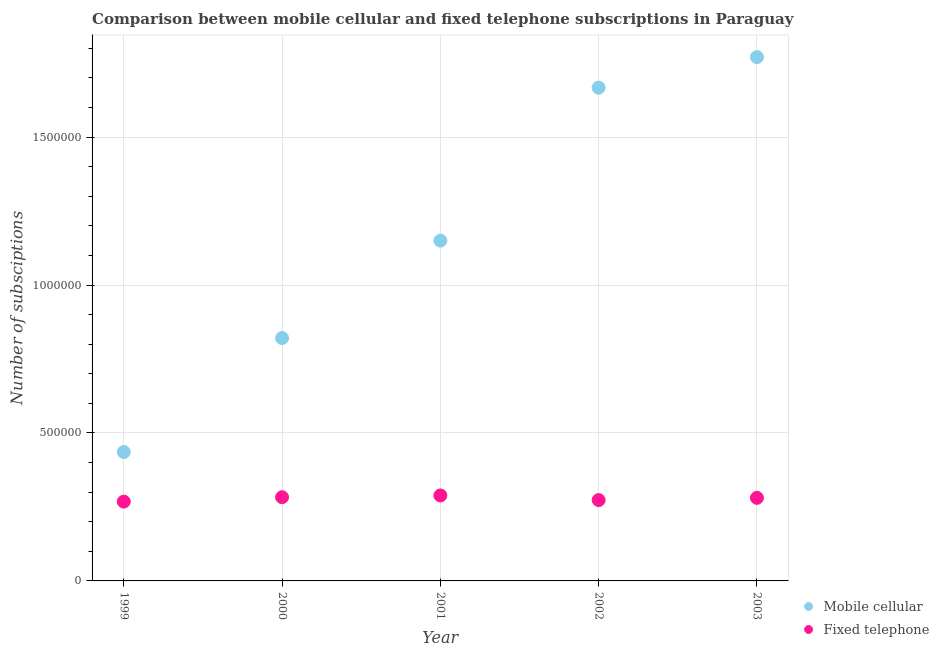What is the number of mobile cellular subscriptions in 1999?
Give a very brief answer. 4.36e+05. Across all years, what is the maximum number of fixed telephone subscriptions?
Offer a very short reply. 2.89e+05. Across all years, what is the minimum number of fixed telephone subscriptions?
Offer a very short reply. 2.68e+05. What is the total number of mobile cellular subscriptions in the graph?
Offer a very short reply. 5.84e+06. What is the difference between the number of mobile cellular subscriptions in 1999 and that in 2001?
Offer a very short reply. -7.14e+05. What is the difference between the number of mobile cellular subscriptions in 2001 and the number of fixed telephone subscriptions in 2000?
Your answer should be very brief. 8.67e+05. What is the average number of fixed telephone subscriptions per year?
Your response must be concise. 2.79e+05. In the year 2003, what is the difference between the number of mobile cellular subscriptions and number of fixed telephone subscriptions?
Provide a short and direct response. 1.49e+06. In how many years, is the number of fixed telephone subscriptions greater than 500000?
Keep it short and to the point. 0. What is the ratio of the number of fixed telephone subscriptions in 1999 to that in 2000?
Provide a short and direct response. 0.95. Is the difference between the number of mobile cellular subscriptions in 2000 and 2003 greater than the difference between the number of fixed telephone subscriptions in 2000 and 2003?
Give a very brief answer. No. What is the difference between the highest and the second highest number of mobile cellular subscriptions?
Keep it short and to the point. 1.03e+05. What is the difference between the highest and the lowest number of fixed telephone subscriptions?
Your answer should be very brief. 2.07e+04. Is the sum of the number of fixed telephone subscriptions in 2001 and 2002 greater than the maximum number of mobile cellular subscriptions across all years?
Offer a very short reply. No. Does the number of mobile cellular subscriptions monotonically increase over the years?
Ensure brevity in your answer.  Yes. Is the number of mobile cellular subscriptions strictly greater than the number of fixed telephone subscriptions over the years?
Offer a very short reply. Yes. Is the number of fixed telephone subscriptions strictly less than the number of mobile cellular subscriptions over the years?
Your response must be concise. Yes. Are the values on the major ticks of Y-axis written in scientific E-notation?
Offer a terse response. No. Does the graph contain any zero values?
Offer a very short reply. No. Does the graph contain grids?
Your response must be concise. Yes. What is the title of the graph?
Offer a terse response. Comparison between mobile cellular and fixed telephone subscriptions in Paraguay. Does "Drinking water services" appear as one of the legend labels in the graph?
Offer a terse response. No. What is the label or title of the X-axis?
Your answer should be very brief. Year. What is the label or title of the Y-axis?
Keep it short and to the point. Number of subsciptions. What is the Number of subsciptions of Mobile cellular in 1999?
Offer a very short reply. 4.36e+05. What is the Number of subsciptions of Fixed telephone in 1999?
Offer a very short reply. 2.68e+05. What is the Number of subsciptions of Mobile cellular in 2000?
Your response must be concise. 8.21e+05. What is the Number of subsciptions of Fixed telephone in 2000?
Keep it short and to the point. 2.83e+05. What is the Number of subsciptions of Mobile cellular in 2001?
Give a very brief answer. 1.15e+06. What is the Number of subsciptions of Fixed telephone in 2001?
Your answer should be very brief. 2.89e+05. What is the Number of subsciptions of Mobile cellular in 2002?
Give a very brief answer. 1.67e+06. What is the Number of subsciptions in Fixed telephone in 2002?
Provide a succinct answer. 2.73e+05. What is the Number of subsciptions of Mobile cellular in 2003?
Provide a succinct answer. 1.77e+06. What is the Number of subsciptions of Fixed telephone in 2003?
Your answer should be very brief. 2.81e+05. Across all years, what is the maximum Number of subsciptions of Mobile cellular?
Provide a short and direct response. 1.77e+06. Across all years, what is the maximum Number of subsciptions in Fixed telephone?
Provide a succinct answer. 2.89e+05. Across all years, what is the minimum Number of subsciptions of Mobile cellular?
Your answer should be very brief. 4.36e+05. Across all years, what is the minimum Number of subsciptions in Fixed telephone?
Your response must be concise. 2.68e+05. What is the total Number of subsciptions of Mobile cellular in the graph?
Offer a very short reply. 5.84e+06. What is the total Number of subsciptions in Fixed telephone in the graph?
Your answer should be compact. 1.39e+06. What is the difference between the Number of subsciptions in Mobile cellular in 1999 and that in 2000?
Offer a very short reply. -3.85e+05. What is the difference between the Number of subsciptions of Fixed telephone in 1999 and that in 2000?
Keep it short and to the point. -1.48e+04. What is the difference between the Number of subsciptions in Mobile cellular in 1999 and that in 2001?
Give a very brief answer. -7.14e+05. What is the difference between the Number of subsciptions in Fixed telephone in 1999 and that in 2001?
Give a very brief answer. -2.07e+04. What is the difference between the Number of subsciptions of Mobile cellular in 1999 and that in 2002?
Offer a very short reply. -1.23e+06. What is the difference between the Number of subsciptions of Fixed telephone in 1999 and that in 2002?
Make the answer very short. -5138. What is the difference between the Number of subsciptions of Mobile cellular in 1999 and that in 2003?
Keep it short and to the point. -1.33e+06. What is the difference between the Number of subsciptions of Fixed telephone in 1999 and that in 2003?
Give a very brief answer. -1.27e+04. What is the difference between the Number of subsciptions of Mobile cellular in 2000 and that in 2001?
Give a very brief answer. -3.29e+05. What is the difference between the Number of subsciptions in Fixed telephone in 2000 and that in 2001?
Give a very brief answer. -5909. What is the difference between the Number of subsciptions in Mobile cellular in 2000 and that in 2002?
Your answer should be very brief. -8.46e+05. What is the difference between the Number of subsciptions in Fixed telephone in 2000 and that in 2002?
Offer a very short reply. 9691. What is the difference between the Number of subsciptions in Mobile cellular in 2000 and that in 2003?
Your response must be concise. -9.50e+05. What is the difference between the Number of subsciptions in Fixed telephone in 2000 and that in 2003?
Offer a very short reply. 2119. What is the difference between the Number of subsciptions in Mobile cellular in 2001 and that in 2002?
Your answer should be very brief. -5.17e+05. What is the difference between the Number of subsciptions of Fixed telephone in 2001 and that in 2002?
Your answer should be very brief. 1.56e+04. What is the difference between the Number of subsciptions in Mobile cellular in 2001 and that in 2003?
Provide a short and direct response. -6.20e+05. What is the difference between the Number of subsciptions of Fixed telephone in 2001 and that in 2003?
Make the answer very short. 8028. What is the difference between the Number of subsciptions of Mobile cellular in 2002 and that in 2003?
Ensure brevity in your answer.  -1.03e+05. What is the difference between the Number of subsciptions in Fixed telephone in 2002 and that in 2003?
Keep it short and to the point. -7572. What is the difference between the Number of subsciptions of Mobile cellular in 1999 and the Number of subsciptions of Fixed telephone in 2000?
Ensure brevity in your answer.  1.53e+05. What is the difference between the Number of subsciptions of Mobile cellular in 1999 and the Number of subsciptions of Fixed telephone in 2001?
Keep it short and to the point. 1.47e+05. What is the difference between the Number of subsciptions in Mobile cellular in 1999 and the Number of subsciptions in Fixed telephone in 2002?
Offer a terse response. 1.62e+05. What is the difference between the Number of subsciptions of Mobile cellular in 1999 and the Number of subsciptions of Fixed telephone in 2003?
Your response must be concise. 1.55e+05. What is the difference between the Number of subsciptions of Mobile cellular in 2000 and the Number of subsciptions of Fixed telephone in 2001?
Ensure brevity in your answer.  5.32e+05. What is the difference between the Number of subsciptions in Mobile cellular in 2000 and the Number of subsciptions in Fixed telephone in 2002?
Offer a terse response. 5.48e+05. What is the difference between the Number of subsciptions in Mobile cellular in 2000 and the Number of subsciptions in Fixed telephone in 2003?
Give a very brief answer. 5.40e+05. What is the difference between the Number of subsciptions in Mobile cellular in 2001 and the Number of subsciptions in Fixed telephone in 2002?
Offer a terse response. 8.77e+05. What is the difference between the Number of subsciptions of Mobile cellular in 2001 and the Number of subsciptions of Fixed telephone in 2003?
Offer a terse response. 8.69e+05. What is the difference between the Number of subsciptions of Mobile cellular in 2002 and the Number of subsciptions of Fixed telephone in 2003?
Your response must be concise. 1.39e+06. What is the average Number of subsciptions of Mobile cellular per year?
Provide a succinct answer. 1.17e+06. What is the average Number of subsciptions in Fixed telephone per year?
Make the answer very short. 2.79e+05. In the year 1999, what is the difference between the Number of subsciptions of Mobile cellular and Number of subsciptions of Fixed telephone?
Keep it short and to the point. 1.68e+05. In the year 2000, what is the difference between the Number of subsciptions of Mobile cellular and Number of subsciptions of Fixed telephone?
Offer a very short reply. 5.38e+05. In the year 2001, what is the difference between the Number of subsciptions in Mobile cellular and Number of subsciptions in Fixed telephone?
Offer a very short reply. 8.61e+05. In the year 2002, what is the difference between the Number of subsciptions of Mobile cellular and Number of subsciptions of Fixed telephone?
Your answer should be very brief. 1.39e+06. In the year 2003, what is the difference between the Number of subsciptions of Mobile cellular and Number of subsciptions of Fixed telephone?
Offer a very short reply. 1.49e+06. What is the ratio of the Number of subsciptions in Mobile cellular in 1999 to that in 2000?
Offer a terse response. 0.53. What is the ratio of the Number of subsciptions in Fixed telephone in 1999 to that in 2000?
Offer a very short reply. 0.95. What is the ratio of the Number of subsciptions of Mobile cellular in 1999 to that in 2001?
Your answer should be compact. 0.38. What is the ratio of the Number of subsciptions in Fixed telephone in 1999 to that in 2001?
Your answer should be very brief. 0.93. What is the ratio of the Number of subsciptions in Mobile cellular in 1999 to that in 2002?
Ensure brevity in your answer.  0.26. What is the ratio of the Number of subsciptions of Fixed telephone in 1999 to that in 2002?
Your answer should be very brief. 0.98. What is the ratio of the Number of subsciptions of Mobile cellular in 1999 to that in 2003?
Ensure brevity in your answer.  0.25. What is the ratio of the Number of subsciptions of Fixed telephone in 1999 to that in 2003?
Your answer should be compact. 0.95. What is the ratio of the Number of subsciptions of Mobile cellular in 2000 to that in 2001?
Give a very brief answer. 0.71. What is the ratio of the Number of subsciptions of Fixed telephone in 2000 to that in 2001?
Make the answer very short. 0.98. What is the ratio of the Number of subsciptions in Mobile cellular in 2000 to that in 2002?
Keep it short and to the point. 0.49. What is the ratio of the Number of subsciptions in Fixed telephone in 2000 to that in 2002?
Your response must be concise. 1.04. What is the ratio of the Number of subsciptions in Mobile cellular in 2000 to that in 2003?
Ensure brevity in your answer.  0.46. What is the ratio of the Number of subsciptions of Fixed telephone in 2000 to that in 2003?
Offer a terse response. 1.01. What is the ratio of the Number of subsciptions in Mobile cellular in 2001 to that in 2002?
Offer a terse response. 0.69. What is the ratio of the Number of subsciptions of Fixed telephone in 2001 to that in 2002?
Ensure brevity in your answer.  1.06. What is the ratio of the Number of subsciptions of Mobile cellular in 2001 to that in 2003?
Your response must be concise. 0.65. What is the ratio of the Number of subsciptions in Fixed telephone in 2001 to that in 2003?
Keep it short and to the point. 1.03. What is the ratio of the Number of subsciptions in Mobile cellular in 2002 to that in 2003?
Ensure brevity in your answer.  0.94. What is the difference between the highest and the second highest Number of subsciptions of Mobile cellular?
Make the answer very short. 1.03e+05. What is the difference between the highest and the second highest Number of subsciptions of Fixed telephone?
Give a very brief answer. 5909. What is the difference between the highest and the lowest Number of subsciptions of Mobile cellular?
Make the answer very short. 1.33e+06. What is the difference between the highest and the lowest Number of subsciptions in Fixed telephone?
Offer a terse response. 2.07e+04. 